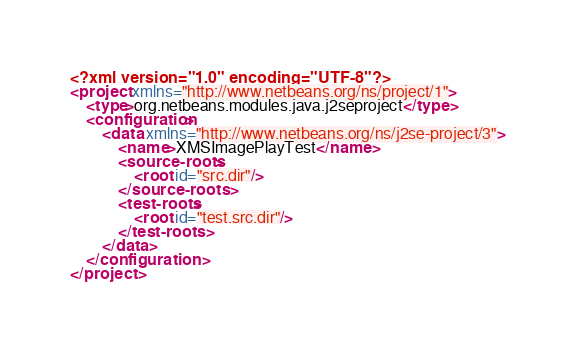<code> <loc_0><loc_0><loc_500><loc_500><_XML_><?xml version="1.0" encoding="UTF-8"?>
<project xmlns="http://www.netbeans.org/ns/project/1">
    <type>org.netbeans.modules.java.j2seproject</type>
    <configuration>
        <data xmlns="http://www.netbeans.org/ns/j2se-project/3">
            <name>XMSImagePlayTest</name>
            <source-roots>
                <root id="src.dir"/>
            </source-roots>
            <test-roots>
                <root id="test.src.dir"/>
            </test-roots>
        </data>
    </configuration>
</project>
</code> 